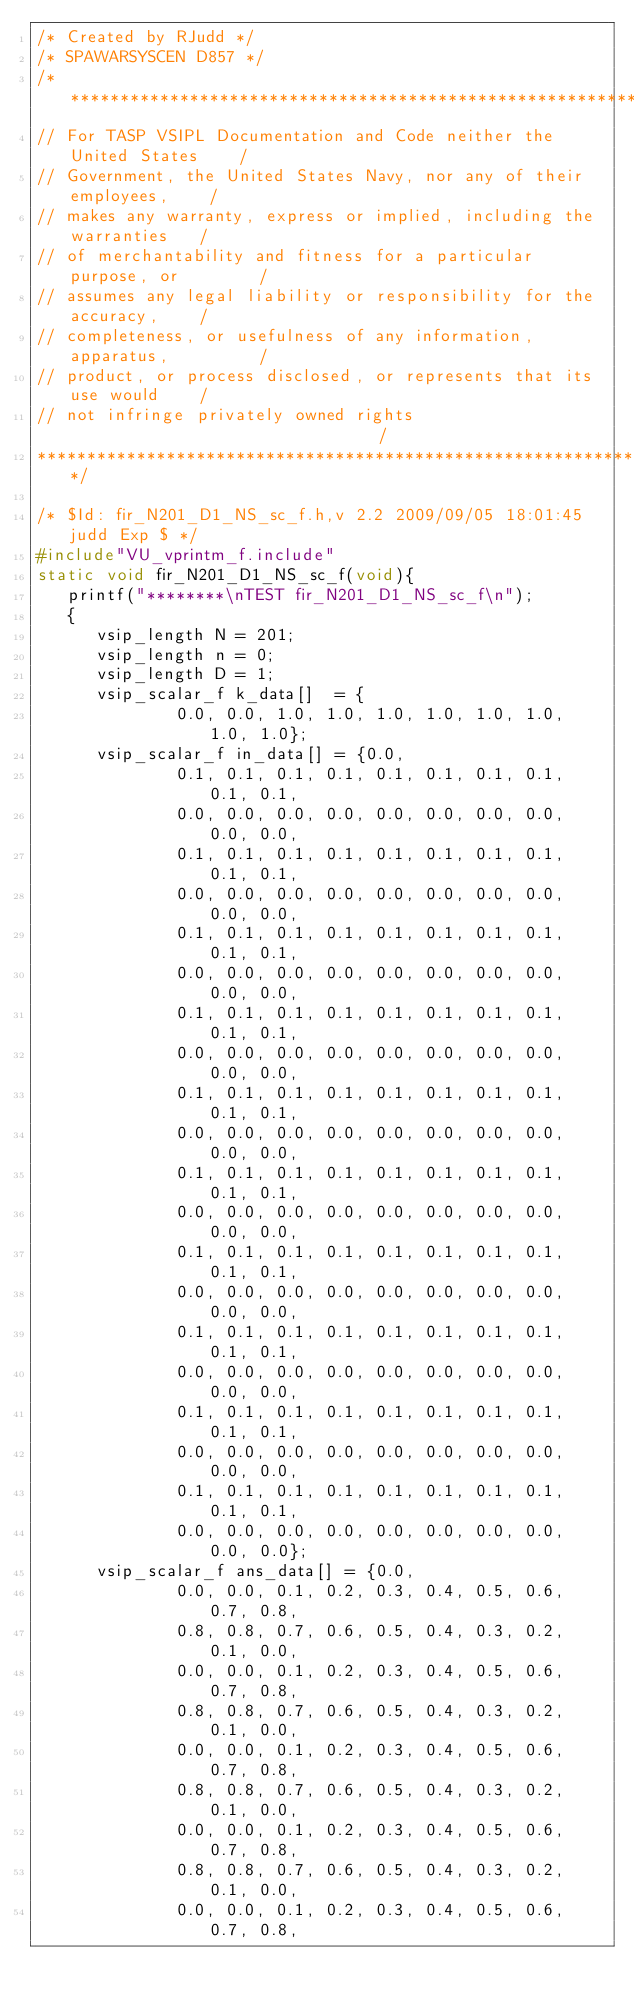<code> <loc_0><loc_0><loc_500><loc_500><_C_>/* Created by RJudd */
/* SPAWARSYSCEN D857 */
/**********************************************************************
// For TASP VSIPL Documentation and Code neither the United States    /
// Government, the United States Navy, nor any of their employees,    /
// makes any warranty, express or implied, including the warranties   /
// of merchantability and fitness for a particular purpose, or        /
// assumes any legal liability or responsibility for the accuracy,    /
// completeness, or usefulness of any information, apparatus,         /
// product, or process disclosed, or represents that its use would    /
// not infringe privately owned rights                                /
**********************************************************************/

/* $Id: fir_N201_D1_NS_sc_f.h,v 2.2 2009/09/05 18:01:45 judd Exp $ */
#include"VU_vprintm_f.include"
static void fir_N201_D1_NS_sc_f(void){
   printf("********\nTEST fir_N201_D1_NS_sc_f\n");
   {
      vsip_length N = 201;
      vsip_length n = 0;
      vsip_length D = 1;
      vsip_scalar_f k_data[]  = {
              0.0, 0.0, 1.0, 1.0, 1.0, 1.0, 1.0, 1.0, 1.0, 1.0};
      vsip_scalar_f in_data[] = {0.0,
              0.1, 0.1, 0.1, 0.1, 0.1, 0.1, 0.1, 0.1, 0.1, 0.1,
              0.0, 0.0, 0.0, 0.0, 0.0, 0.0, 0.0, 0.0, 0.0, 0.0,
              0.1, 0.1, 0.1, 0.1, 0.1, 0.1, 0.1, 0.1, 0.1, 0.1,
              0.0, 0.0, 0.0, 0.0, 0.0, 0.0, 0.0, 0.0, 0.0, 0.0,
              0.1, 0.1, 0.1, 0.1, 0.1, 0.1, 0.1, 0.1, 0.1, 0.1,
              0.0, 0.0, 0.0, 0.0, 0.0, 0.0, 0.0, 0.0, 0.0, 0.0,
              0.1, 0.1, 0.1, 0.1, 0.1, 0.1, 0.1, 0.1, 0.1, 0.1,
              0.0, 0.0, 0.0, 0.0, 0.0, 0.0, 0.0, 0.0, 0.0, 0.0,
              0.1, 0.1, 0.1, 0.1, 0.1, 0.1, 0.1, 0.1, 0.1, 0.1,
              0.0, 0.0, 0.0, 0.0, 0.0, 0.0, 0.0, 0.0, 0.0, 0.0,
              0.1, 0.1, 0.1, 0.1, 0.1, 0.1, 0.1, 0.1, 0.1, 0.1,
              0.0, 0.0, 0.0, 0.0, 0.0, 0.0, 0.0, 0.0, 0.0, 0.0,
              0.1, 0.1, 0.1, 0.1, 0.1, 0.1, 0.1, 0.1, 0.1, 0.1,
              0.0, 0.0, 0.0, 0.0, 0.0, 0.0, 0.0, 0.0, 0.0, 0.0,
              0.1, 0.1, 0.1, 0.1, 0.1, 0.1, 0.1, 0.1, 0.1, 0.1,
              0.0, 0.0, 0.0, 0.0, 0.0, 0.0, 0.0, 0.0, 0.0, 0.0,
              0.1, 0.1, 0.1, 0.1, 0.1, 0.1, 0.1, 0.1, 0.1, 0.1,
              0.0, 0.0, 0.0, 0.0, 0.0, 0.0, 0.0, 0.0, 0.0, 0.0,
              0.1, 0.1, 0.1, 0.1, 0.1, 0.1, 0.1, 0.1, 0.1, 0.1,
              0.0, 0.0, 0.0, 0.0, 0.0, 0.0, 0.0, 0.0, 0.0, 0.0};
      vsip_scalar_f ans_data[] = {0.0,
              0.0, 0.0, 0.1, 0.2, 0.3, 0.4, 0.5, 0.6, 0.7, 0.8,
              0.8, 0.8, 0.7, 0.6, 0.5, 0.4, 0.3, 0.2, 0.1, 0.0,
              0.0, 0.0, 0.1, 0.2, 0.3, 0.4, 0.5, 0.6, 0.7, 0.8,
              0.8, 0.8, 0.7, 0.6, 0.5, 0.4, 0.3, 0.2, 0.1, 0.0,
              0.0, 0.0, 0.1, 0.2, 0.3, 0.4, 0.5, 0.6, 0.7, 0.8,
              0.8, 0.8, 0.7, 0.6, 0.5, 0.4, 0.3, 0.2, 0.1, 0.0,
              0.0, 0.0, 0.1, 0.2, 0.3, 0.4, 0.5, 0.6, 0.7, 0.8,
              0.8, 0.8, 0.7, 0.6, 0.5, 0.4, 0.3, 0.2, 0.1, 0.0,
              0.0, 0.0, 0.1, 0.2, 0.3, 0.4, 0.5, 0.6, 0.7, 0.8,</code> 